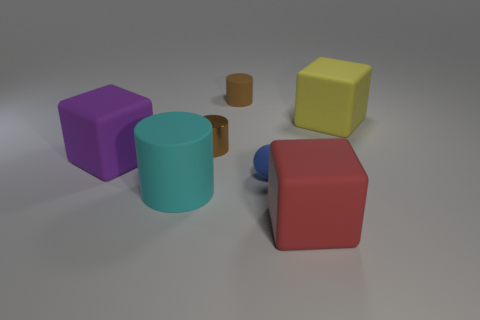Subtract all cyan cylinders. How many cylinders are left? 2 Subtract all big yellow matte cubes. How many cubes are left? 2 Subtract 1 red blocks. How many objects are left? 6 Subtract all spheres. How many objects are left? 6 Subtract 3 cylinders. How many cylinders are left? 0 Subtract all gray cylinders. Subtract all yellow spheres. How many cylinders are left? 3 Subtract all green balls. How many yellow blocks are left? 1 Subtract all yellow things. Subtract all tiny matte cylinders. How many objects are left? 5 Add 3 big cyan rubber cylinders. How many big cyan rubber cylinders are left? 4 Add 2 large red blocks. How many large red blocks exist? 3 